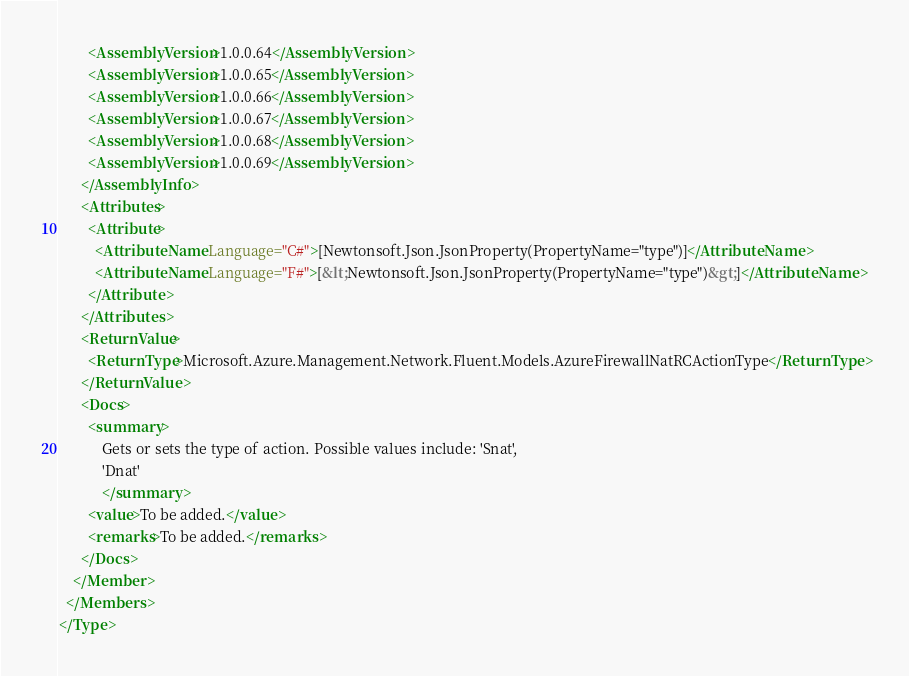Convert code to text. <code><loc_0><loc_0><loc_500><loc_500><_XML_>        <AssemblyVersion>1.0.0.64</AssemblyVersion>
        <AssemblyVersion>1.0.0.65</AssemblyVersion>
        <AssemblyVersion>1.0.0.66</AssemblyVersion>
        <AssemblyVersion>1.0.0.67</AssemblyVersion>
        <AssemblyVersion>1.0.0.68</AssemblyVersion>
        <AssemblyVersion>1.0.0.69</AssemblyVersion>
      </AssemblyInfo>
      <Attributes>
        <Attribute>
          <AttributeName Language="C#">[Newtonsoft.Json.JsonProperty(PropertyName="type")]</AttributeName>
          <AttributeName Language="F#">[&lt;Newtonsoft.Json.JsonProperty(PropertyName="type")&gt;]</AttributeName>
        </Attribute>
      </Attributes>
      <ReturnValue>
        <ReturnType>Microsoft.Azure.Management.Network.Fluent.Models.AzureFirewallNatRCActionType</ReturnType>
      </ReturnValue>
      <Docs>
        <summary>
            Gets or sets the type of action. Possible values include: 'Snat',
            'Dnat'
            </summary>
        <value>To be added.</value>
        <remarks>To be added.</remarks>
      </Docs>
    </Member>
  </Members>
</Type>
</code> 